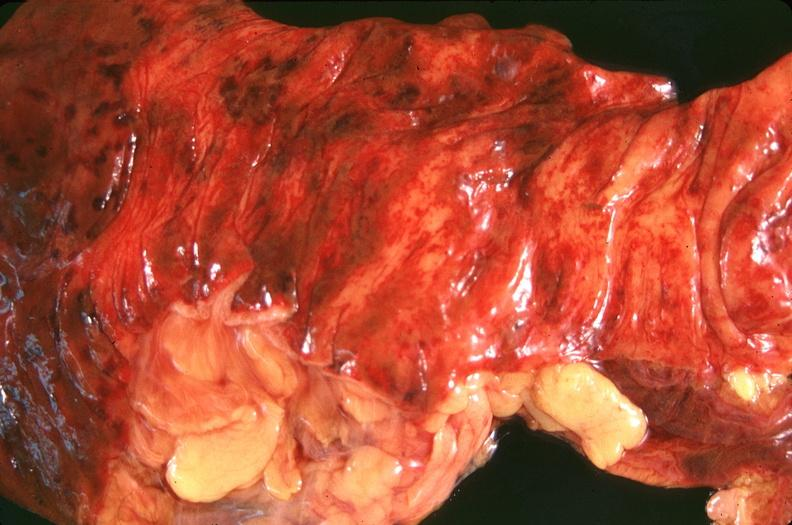what is present?
Answer the question using a single word or phrase. Gastrointestinal 